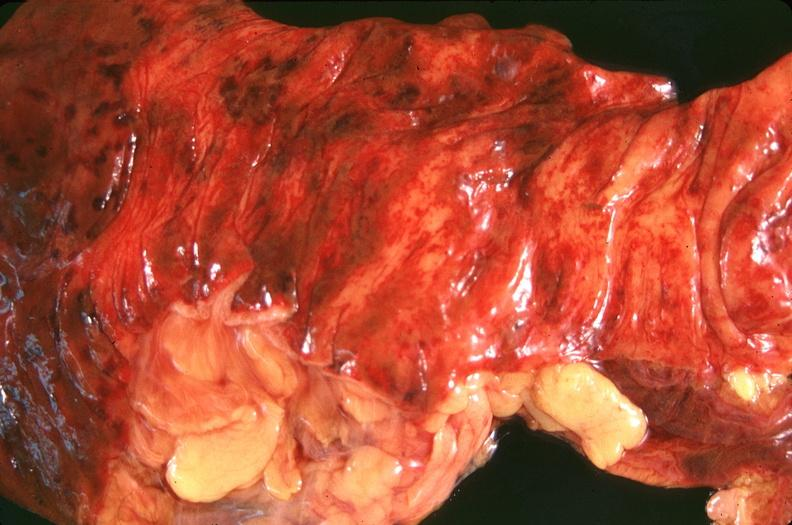what is present?
Answer the question using a single word or phrase. Gastrointestinal 